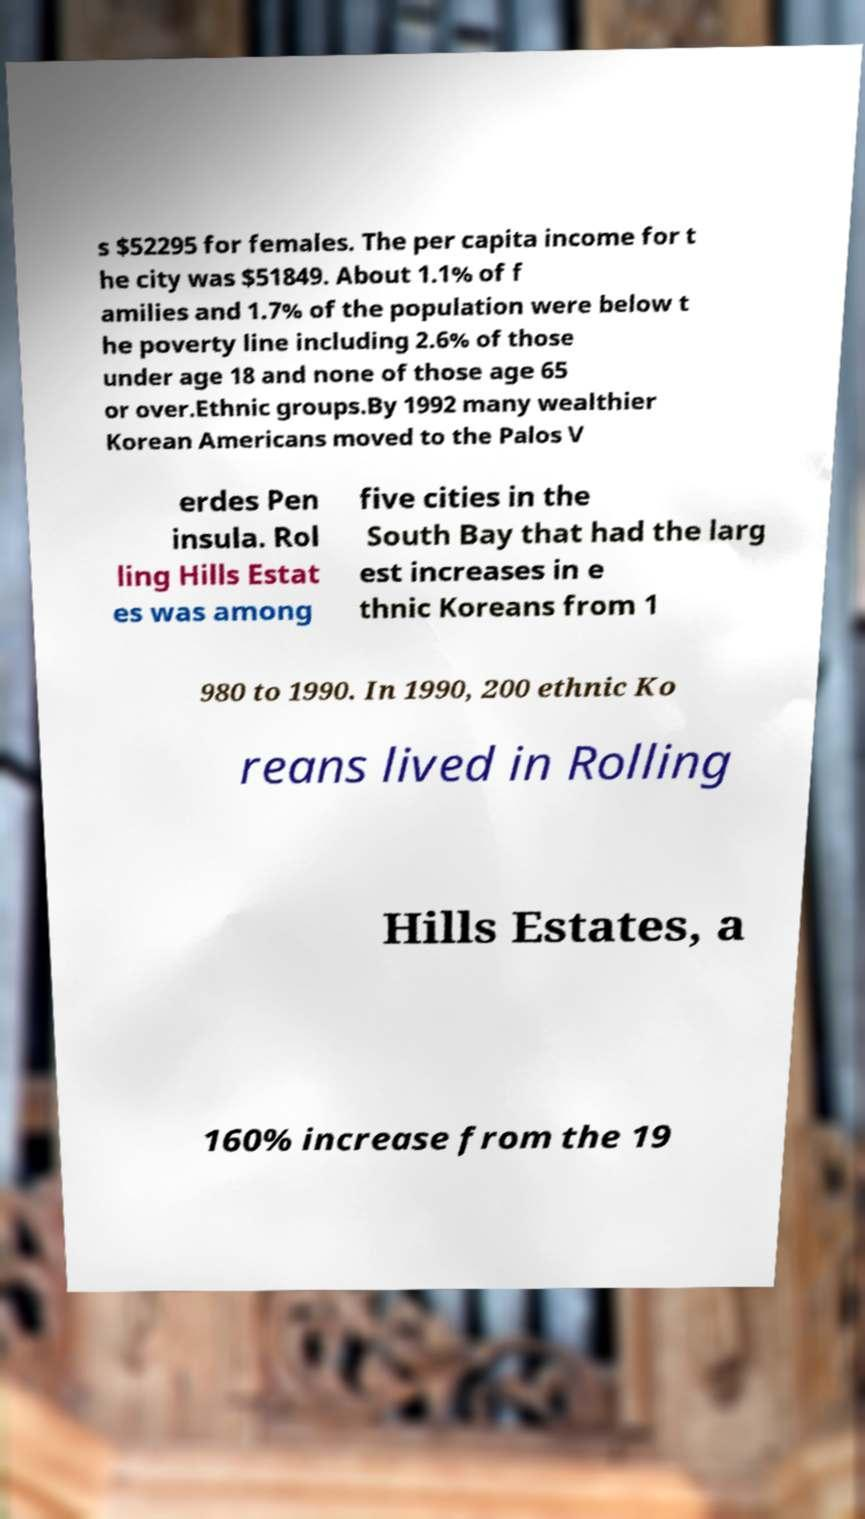Please read and relay the text visible in this image. What does it say? s $52295 for females. The per capita income for t he city was $51849. About 1.1% of f amilies and 1.7% of the population were below t he poverty line including 2.6% of those under age 18 and none of those age 65 or over.Ethnic groups.By 1992 many wealthier Korean Americans moved to the Palos V erdes Pen insula. Rol ling Hills Estat es was among five cities in the South Bay that had the larg est increases in e thnic Koreans from 1 980 to 1990. In 1990, 200 ethnic Ko reans lived in Rolling Hills Estates, a 160% increase from the 19 